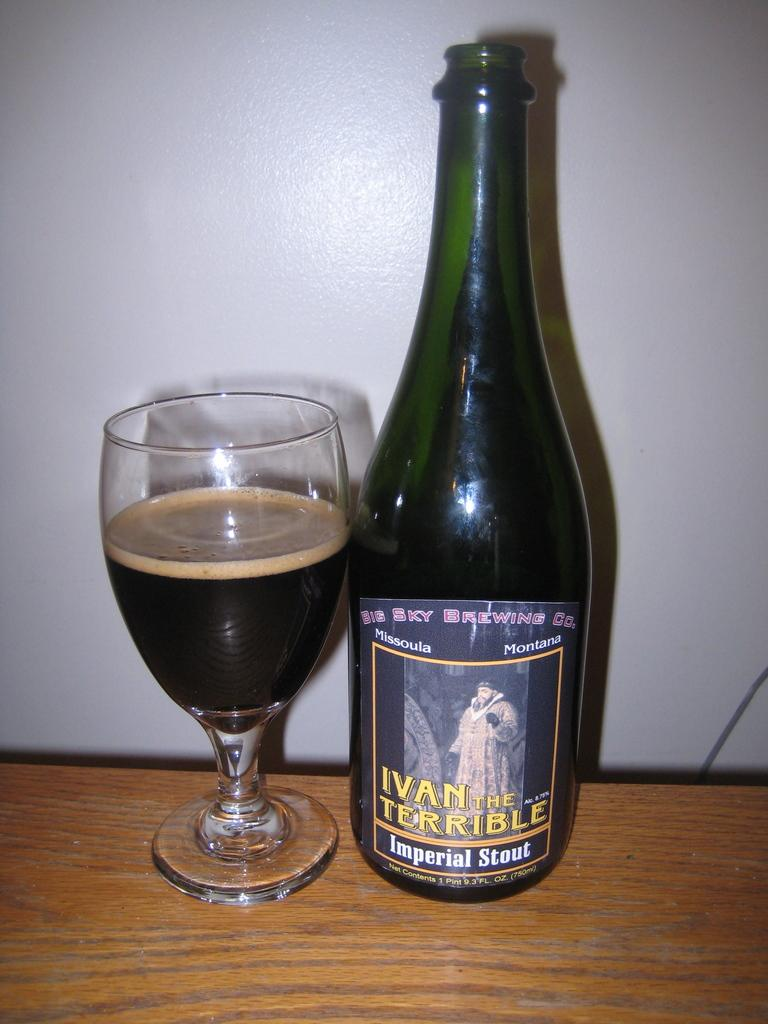What is on the table in the image? There is a glass and a bottle on the table in the image. What else can be seen in the image besides the table? There is a wall in the image. What type of flag is flying on the slope in the image? There is no flag or slope present in the image; it only features a table with a glass and a bottle, and a wall in the background. 